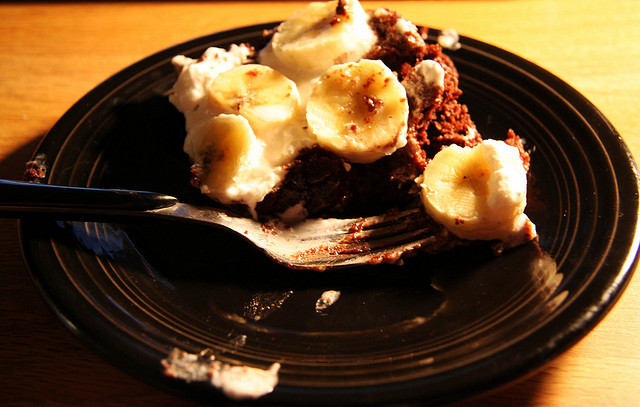Describe the setting in which the food is presented. The food is placed on a wooden surface, suggesting a homely and casual dining setting. The warm lighting casts appealing shadows, highlighting the texture of the cake and bananas. 